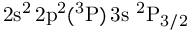<formula> <loc_0><loc_0><loc_500><loc_500>2 s ^ { 2 } \, 2 p ^ { 2 } ( ^ { 3 } P ) \, 3 s ^ { 2 } P _ { 3 / 2 }</formula> 